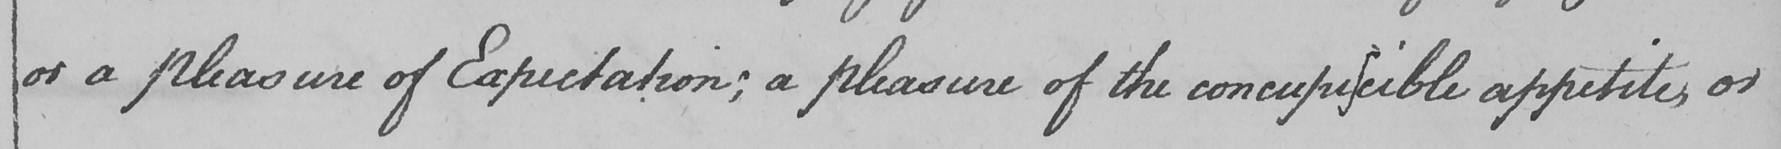What text is written in this handwritten line? or a pleasure of Expectation ; a pleasure of the concupiscible appetites or 